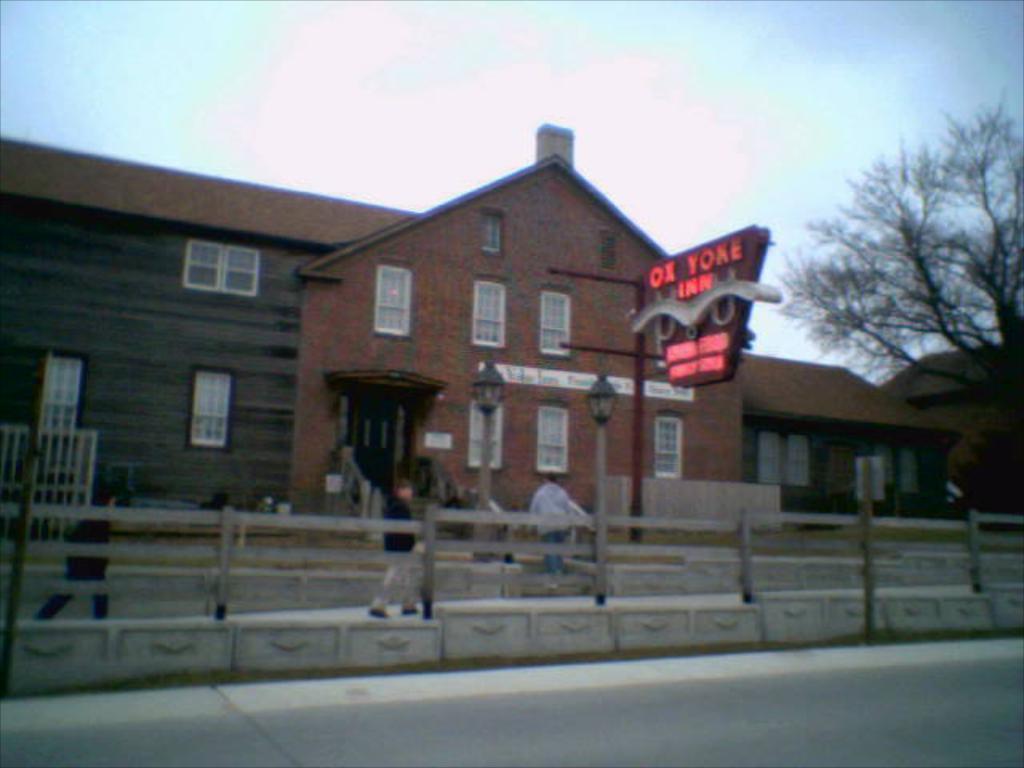Describe this image in one or two sentences. In this image I can see the building, windows, light poles, board, fencing, trees and few people. I can see the sky. 